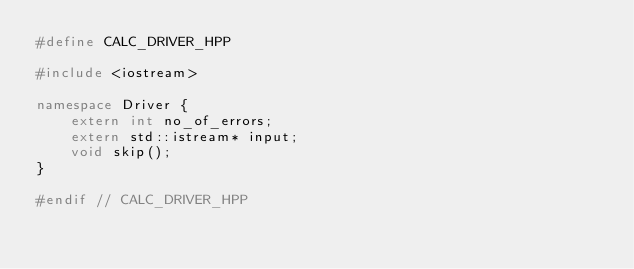<code> <loc_0><loc_0><loc_500><loc_500><_C++_>#define CALC_DRIVER_HPP

#include <iostream>

namespace Driver {
    extern int no_of_errors;
    extern std::istream* input;
    void skip();
}

#endif // CALC_DRIVER_HPP

</code> 